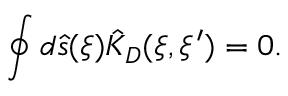<formula> <loc_0><loc_0><loc_500><loc_500>\oint { d } \hat { s } ( \xi ) { \hat { K } _ { D } } ( \xi , \xi ^ { \prime } ) = 0 .</formula> 